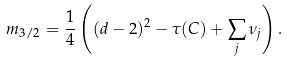Convert formula to latex. <formula><loc_0><loc_0><loc_500><loc_500>m _ { 3 / 2 } = \frac { 1 } { 4 } \left ( ( d - 2 ) ^ { 2 } - \tau ( C ) + \sum _ { j } \nu _ { j } \right ) .</formula> 